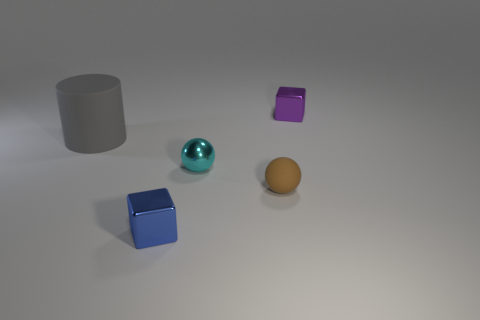What is the size of the object that is behind the brown rubber thing and left of the metal sphere?
Offer a terse response. Large. Does the object that is on the right side of the tiny brown thing have the same shape as the rubber thing that is right of the large rubber cylinder?
Provide a short and direct response. No. How many objects are either brown rubber things or tiny shiny cubes?
Offer a very short reply. 3. There is another metal object that is the same shape as the tiny blue thing; what size is it?
Offer a terse response. Small. Is the number of small brown matte balls that are to the left of the metallic ball greater than the number of green spheres?
Provide a succinct answer. No. Are the blue block and the small brown object made of the same material?
Keep it short and to the point. No. How many objects are things in front of the big thing or tiny shiny cubes that are in front of the tiny purple shiny thing?
Offer a very short reply. 3. There is another tiny metal object that is the same shape as the tiny purple object; what color is it?
Make the answer very short. Blue. How many other small spheres have the same color as the metal ball?
Your answer should be compact. 0. Is the small metallic sphere the same color as the tiny matte sphere?
Ensure brevity in your answer.  No. 